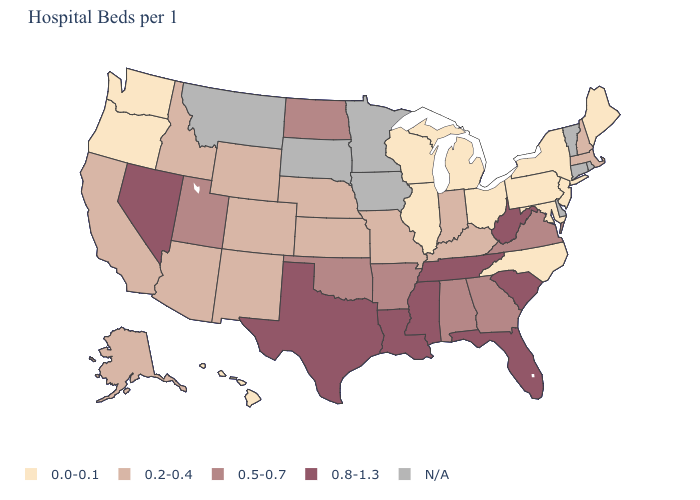Does the first symbol in the legend represent the smallest category?
Concise answer only. Yes. Does Texas have the highest value in the USA?
Quick response, please. Yes. What is the value of Maryland?
Answer briefly. 0.0-0.1. What is the value of Mississippi?
Be succinct. 0.8-1.3. Name the states that have a value in the range N/A?
Give a very brief answer. Connecticut, Delaware, Iowa, Minnesota, Montana, Rhode Island, South Dakota, Vermont. Does the map have missing data?
Quick response, please. Yes. What is the value of New York?
Write a very short answer. 0.0-0.1. What is the value of New Hampshire?
Write a very short answer. 0.2-0.4. What is the value of Alabama?
Keep it brief. 0.5-0.7. Among the states that border West Virginia , which have the highest value?
Quick response, please. Virginia. Which states have the lowest value in the USA?
Answer briefly. Hawaii, Illinois, Maine, Maryland, Michigan, New Jersey, New York, North Carolina, Ohio, Oregon, Pennsylvania, Washington, Wisconsin. What is the value of New Hampshire?
Short answer required. 0.2-0.4. What is the value of West Virginia?
Keep it brief. 0.8-1.3. Name the states that have a value in the range 0.0-0.1?
Give a very brief answer. Hawaii, Illinois, Maine, Maryland, Michigan, New Jersey, New York, North Carolina, Ohio, Oregon, Pennsylvania, Washington, Wisconsin. What is the value of Illinois?
Keep it brief. 0.0-0.1. 